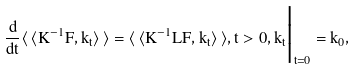<formula> <loc_0><loc_0><loc_500><loc_500>\frac { d } { d t } \langle \, \langle K ^ { - 1 } F , k _ { t } \rangle \, \rangle = \langle \, \langle K ^ { - 1 } L F , k _ { t } \rangle \, \rangle , t > 0 , k _ { t } \Big | _ { t = 0 } = k _ { 0 } ,</formula> 